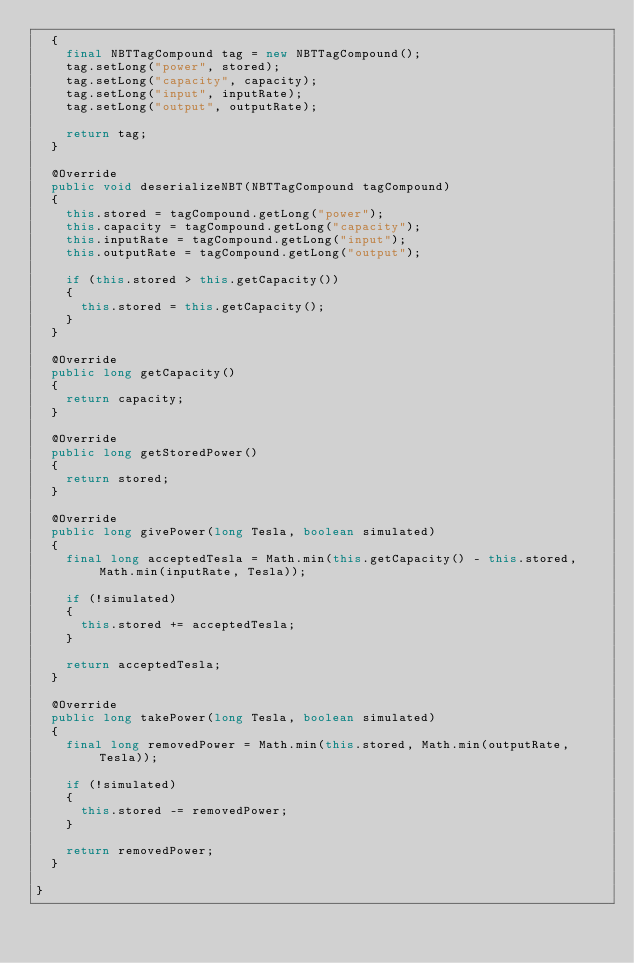Convert code to text. <code><loc_0><loc_0><loc_500><loc_500><_Java_>	{
		final NBTTagCompound tag = new NBTTagCompound();
		tag.setLong("power", stored);
		tag.setLong("capacity", capacity);
		tag.setLong("input", inputRate);
		tag.setLong("output", outputRate);
		
		return tag;
	}
	
	@Override
	public void deserializeNBT(NBTTagCompound tagCompound)
	{
		this.stored = tagCompound.getLong("power");
		this.capacity = tagCompound.getLong("capacity");
		this.inputRate = tagCompound.getLong("input");
		this.outputRate = tagCompound.getLong("output");
			
		if (this.stored > this.getCapacity())
		{
			this.stored = this.getCapacity();
		}
	}

	@Override
	public long getCapacity()
	{
		return capacity;
	}

	@Override
	public long getStoredPower()
	{
		return stored;
	}

	@Override
	public long givePower(long Tesla, boolean simulated)
	{
		final long acceptedTesla = Math.min(this.getCapacity() - this.stored, Math.min(inputRate, Tesla));
		
		if (!simulated)
		{
			this.stored += acceptedTesla;
		}
			
		return acceptedTesla;
	}

	@Override
	public long takePower(long Tesla, boolean simulated)
	{
		final long removedPower = Math.min(this.stored, Math.min(outputRate, Tesla));
		
		if (!simulated)
		{
			this.stored -= removedPower;
		}
			
		return removedPower;
	}

}
</code> 